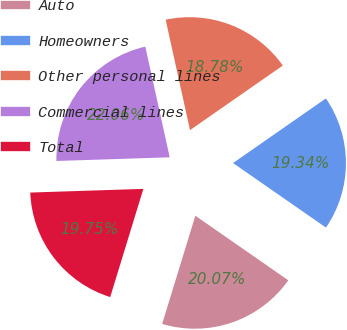Convert chart to OTSL. <chart><loc_0><loc_0><loc_500><loc_500><pie_chart><fcel>Auto<fcel>Homeowners<fcel>Other personal lines<fcel>Commercial lines<fcel>Total<nl><fcel>20.07%<fcel>19.34%<fcel>18.78%<fcel>22.06%<fcel>19.75%<nl></chart> 